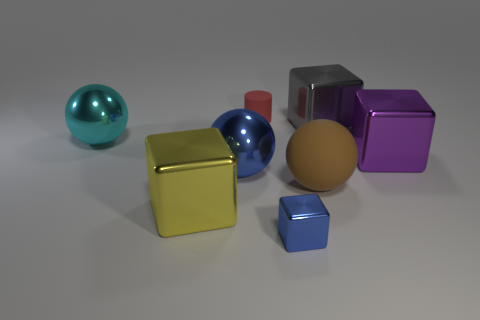What number of spheres are shiny things or big purple objects?
Your response must be concise. 2. How many yellow things have the same size as the rubber ball?
Ensure brevity in your answer.  1. What number of tiny blue metal blocks are in front of the tiny thing in front of the brown sphere?
Provide a short and direct response. 0. What size is the metal block that is both behind the blue ball and in front of the gray block?
Your response must be concise. Large. Is the number of big red metallic things greater than the number of large purple shiny things?
Your answer should be compact. No. Is there a large metal thing that has the same color as the tiny metal block?
Your answer should be compact. Yes. Does the metallic sphere that is on the left side of the yellow cube have the same size as the gray cube?
Your answer should be compact. Yes. Is the number of tiny blue shiny objects less than the number of big things?
Ensure brevity in your answer.  Yes. Is there a tiny blue object that has the same material as the yellow cube?
Keep it short and to the point. Yes. There is a blue metallic object behind the matte sphere; what shape is it?
Your answer should be very brief. Sphere. 